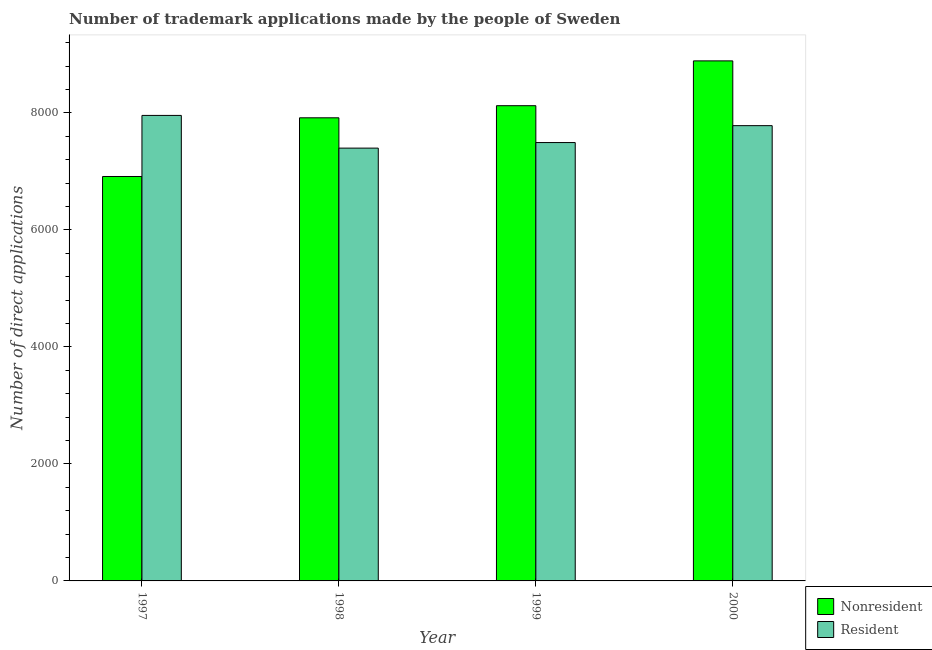Are the number of bars per tick equal to the number of legend labels?
Ensure brevity in your answer.  Yes. Are the number of bars on each tick of the X-axis equal?
Provide a succinct answer. Yes. How many bars are there on the 4th tick from the right?
Provide a short and direct response. 2. What is the label of the 3rd group of bars from the left?
Give a very brief answer. 1999. What is the number of trademark applications made by non residents in 1997?
Your answer should be very brief. 6912. Across all years, what is the maximum number of trademark applications made by residents?
Ensure brevity in your answer.  7956. Across all years, what is the minimum number of trademark applications made by non residents?
Your answer should be very brief. 6912. In which year was the number of trademark applications made by residents maximum?
Your response must be concise. 1997. What is the total number of trademark applications made by non residents in the graph?
Provide a succinct answer. 3.18e+04. What is the difference between the number of trademark applications made by non residents in 1998 and that in 1999?
Provide a succinct answer. -207. What is the difference between the number of trademark applications made by non residents in 1998 and the number of trademark applications made by residents in 1999?
Ensure brevity in your answer.  -207. What is the average number of trademark applications made by non residents per year?
Ensure brevity in your answer.  7959.25. In how many years, is the number of trademark applications made by non residents greater than 2800?
Make the answer very short. 4. What is the ratio of the number of trademark applications made by residents in 1998 to that in 1999?
Your answer should be compact. 0.99. Is the number of trademark applications made by non residents in 1998 less than that in 2000?
Provide a succinct answer. Yes. Is the difference between the number of trademark applications made by non residents in 1997 and 1999 greater than the difference between the number of trademark applications made by residents in 1997 and 1999?
Your answer should be compact. No. What is the difference between the highest and the second highest number of trademark applications made by non residents?
Ensure brevity in your answer.  766. What is the difference between the highest and the lowest number of trademark applications made by non residents?
Your answer should be compact. 1976. Is the sum of the number of trademark applications made by non residents in 1998 and 2000 greater than the maximum number of trademark applications made by residents across all years?
Make the answer very short. Yes. What does the 2nd bar from the left in 2000 represents?
Your answer should be very brief. Resident. What does the 2nd bar from the right in 1998 represents?
Give a very brief answer. Nonresident. Are all the bars in the graph horizontal?
Your answer should be very brief. No. What is the difference between two consecutive major ticks on the Y-axis?
Provide a succinct answer. 2000. Does the graph contain any zero values?
Provide a short and direct response. No. Does the graph contain grids?
Keep it short and to the point. No. How many legend labels are there?
Make the answer very short. 2. What is the title of the graph?
Make the answer very short. Number of trademark applications made by the people of Sweden. Does "GDP at market prices" appear as one of the legend labels in the graph?
Ensure brevity in your answer.  No. What is the label or title of the X-axis?
Make the answer very short. Year. What is the label or title of the Y-axis?
Your answer should be compact. Number of direct applications. What is the Number of direct applications in Nonresident in 1997?
Keep it short and to the point. 6912. What is the Number of direct applications in Resident in 1997?
Offer a very short reply. 7956. What is the Number of direct applications of Nonresident in 1998?
Your answer should be very brief. 7915. What is the Number of direct applications in Resident in 1998?
Offer a terse response. 7397. What is the Number of direct applications of Nonresident in 1999?
Your answer should be compact. 8122. What is the Number of direct applications of Resident in 1999?
Offer a very short reply. 7492. What is the Number of direct applications of Nonresident in 2000?
Your answer should be very brief. 8888. What is the Number of direct applications of Resident in 2000?
Give a very brief answer. 7781. Across all years, what is the maximum Number of direct applications in Nonresident?
Your answer should be compact. 8888. Across all years, what is the maximum Number of direct applications in Resident?
Your response must be concise. 7956. Across all years, what is the minimum Number of direct applications in Nonresident?
Ensure brevity in your answer.  6912. Across all years, what is the minimum Number of direct applications of Resident?
Your response must be concise. 7397. What is the total Number of direct applications in Nonresident in the graph?
Provide a short and direct response. 3.18e+04. What is the total Number of direct applications in Resident in the graph?
Give a very brief answer. 3.06e+04. What is the difference between the Number of direct applications in Nonresident in 1997 and that in 1998?
Keep it short and to the point. -1003. What is the difference between the Number of direct applications of Resident in 1997 and that in 1998?
Provide a short and direct response. 559. What is the difference between the Number of direct applications of Nonresident in 1997 and that in 1999?
Make the answer very short. -1210. What is the difference between the Number of direct applications in Resident in 1997 and that in 1999?
Give a very brief answer. 464. What is the difference between the Number of direct applications in Nonresident in 1997 and that in 2000?
Give a very brief answer. -1976. What is the difference between the Number of direct applications in Resident in 1997 and that in 2000?
Your response must be concise. 175. What is the difference between the Number of direct applications of Nonresident in 1998 and that in 1999?
Make the answer very short. -207. What is the difference between the Number of direct applications in Resident in 1998 and that in 1999?
Give a very brief answer. -95. What is the difference between the Number of direct applications of Nonresident in 1998 and that in 2000?
Your answer should be compact. -973. What is the difference between the Number of direct applications of Resident in 1998 and that in 2000?
Your answer should be very brief. -384. What is the difference between the Number of direct applications of Nonresident in 1999 and that in 2000?
Provide a succinct answer. -766. What is the difference between the Number of direct applications of Resident in 1999 and that in 2000?
Keep it short and to the point. -289. What is the difference between the Number of direct applications of Nonresident in 1997 and the Number of direct applications of Resident in 1998?
Your answer should be compact. -485. What is the difference between the Number of direct applications in Nonresident in 1997 and the Number of direct applications in Resident in 1999?
Your answer should be very brief. -580. What is the difference between the Number of direct applications of Nonresident in 1997 and the Number of direct applications of Resident in 2000?
Make the answer very short. -869. What is the difference between the Number of direct applications of Nonresident in 1998 and the Number of direct applications of Resident in 1999?
Provide a succinct answer. 423. What is the difference between the Number of direct applications in Nonresident in 1998 and the Number of direct applications in Resident in 2000?
Offer a terse response. 134. What is the difference between the Number of direct applications in Nonresident in 1999 and the Number of direct applications in Resident in 2000?
Ensure brevity in your answer.  341. What is the average Number of direct applications in Nonresident per year?
Your answer should be compact. 7959.25. What is the average Number of direct applications in Resident per year?
Give a very brief answer. 7656.5. In the year 1997, what is the difference between the Number of direct applications of Nonresident and Number of direct applications of Resident?
Provide a succinct answer. -1044. In the year 1998, what is the difference between the Number of direct applications of Nonresident and Number of direct applications of Resident?
Offer a terse response. 518. In the year 1999, what is the difference between the Number of direct applications of Nonresident and Number of direct applications of Resident?
Make the answer very short. 630. In the year 2000, what is the difference between the Number of direct applications in Nonresident and Number of direct applications in Resident?
Offer a very short reply. 1107. What is the ratio of the Number of direct applications in Nonresident in 1997 to that in 1998?
Give a very brief answer. 0.87. What is the ratio of the Number of direct applications of Resident in 1997 to that in 1998?
Make the answer very short. 1.08. What is the ratio of the Number of direct applications in Nonresident in 1997 to that in 1999?
Offer a very short reply. 0.85. What is the ratio of the Number of direct applications of Resident in 1997 to that in 1999?
Your response must be concise. 1.06. What is the ratio of the Number of direct applications of Nonresident in 1997 to that in 2000?
Offer a very short reply. 0.78. What is the ratio of the Number of direct applications in Resident in 1997 to that in 2000?
Ensure brevity in your answer.  1.02. What is the ratio of the Number of direct applications in Nonresident in 1998 to that in 1999?
Offer a terse response. 0.97. What is the ratio of the Number of direct applications of Resident in 1998 to that in 1999?
Offer a terse response. 0.99. What is the ratio of the Number of direct applications in Nonresident in 1998 to that in 2000?
Ensure brevity in your answer.  0.89. What is the ratio of the Number of direct applications of Resident in 1998 to that in 2000?
Make the answer very short. 0.95. What is the ratio of the Number of direct applications in Nonresident in 1999 to that in 2000?
Offer a terse response. 0.91. What is the ratio of the Number of direct applications in Resident in 1999 to that in 2000?
Your answer should be compact. 0.96. What is the difference between the highest and the second highest Number of direct applications of Nonresident?
Your answer should be compact. 766. What is the difference between the highest and the second highest Number of direct applications of Resident?
Ensure brevity in your answer.  175. What is the difference between the highest and the lowest Number of direct applications of Nonresident?
Your answer should be very brief. 1976. What is the difference between the highest and the lowest Number of direct applications of Resident?
Provide a short and direct response. 559. 